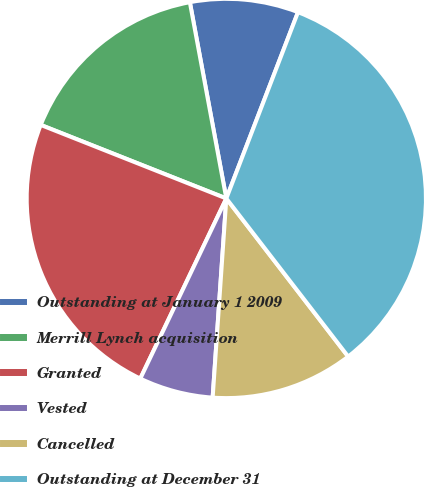Convert chart. <chart><loc_0><loc_0><loc_500><loc_500><pie_chart><fcel>Outstanding at January 1 2009<fcel>Merrill Lynch acquisition<fcel>Granted<fcel>Vested<fcel>Cancelled<fcel>Outstanding at December 31<nl><fcel>8.77%<fcel>16.07%<fcel>23.91%<fcel>6.0%<fcel>11.54%<fcel>33.7%<nl></chart> 